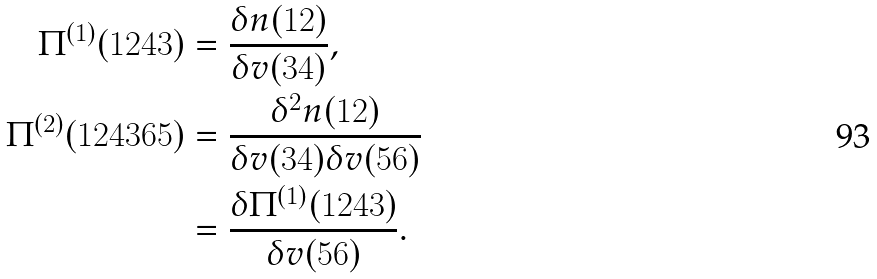<formula> <loc_0><loc_0><loc_500><loc_500>\Pi ^ { ( 1 ) } ( 1 2 4 3 ) & = \frac { \delta n ( 1 2 ) } { \delta v ( 3 4 ) } , \\ \Pi ^ { ( 2 ) } ( 1 2 4 3 6 5 ) & = \frac { \delta ^ { 2 } n ( 1 2 ) } { \delta v ( 3 4 ) \delta v ( 5 6 ) } \\ & = \frac { \delta \Pi ^ { ( 1 ) } ( 1 2 4 3 ) } { \delta v ( 5 6 ) } .</formula> 